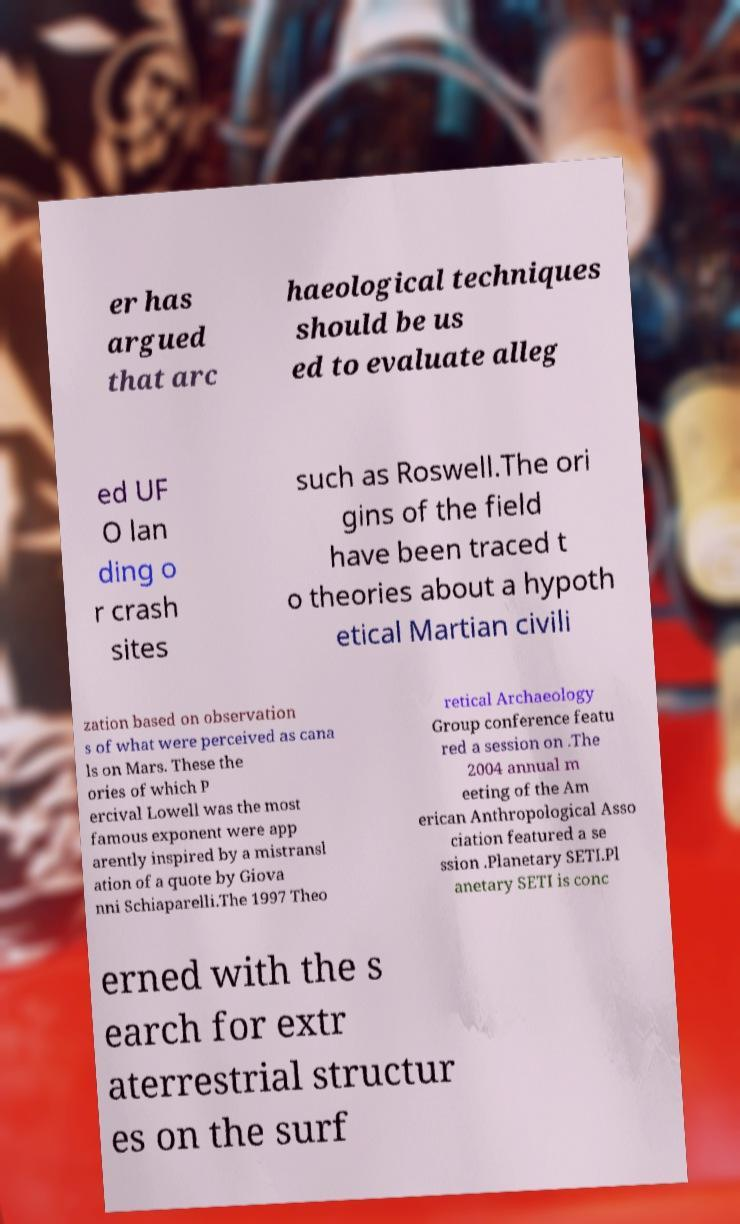Please read and relay the text visible in this image. What does it say? er has argued that arc haeological techniques should be us ed to evaluate alleg ed UF O lan ding o r crash sites such as Roswell.The ori gins of the field have been traced t o theories about a hypoth etical Martian civili zation based on observation s of what were perceived as cana ls on Mars. These the ories of which P ercival Lowell was the most famous exponent were app arently inspired by a mistransl ation of a quote by Giova nni Schiaparelli.The 1997 Theo retical Archaeology Group conference featu red a session on .The 2004 annual m eeting of the Am erican Anthropological Asso ciation featured a se ssion .Planetary SETI.Pl anetary SETI is conc erned with the s earch for extr aterrestrial structur es on the surf 